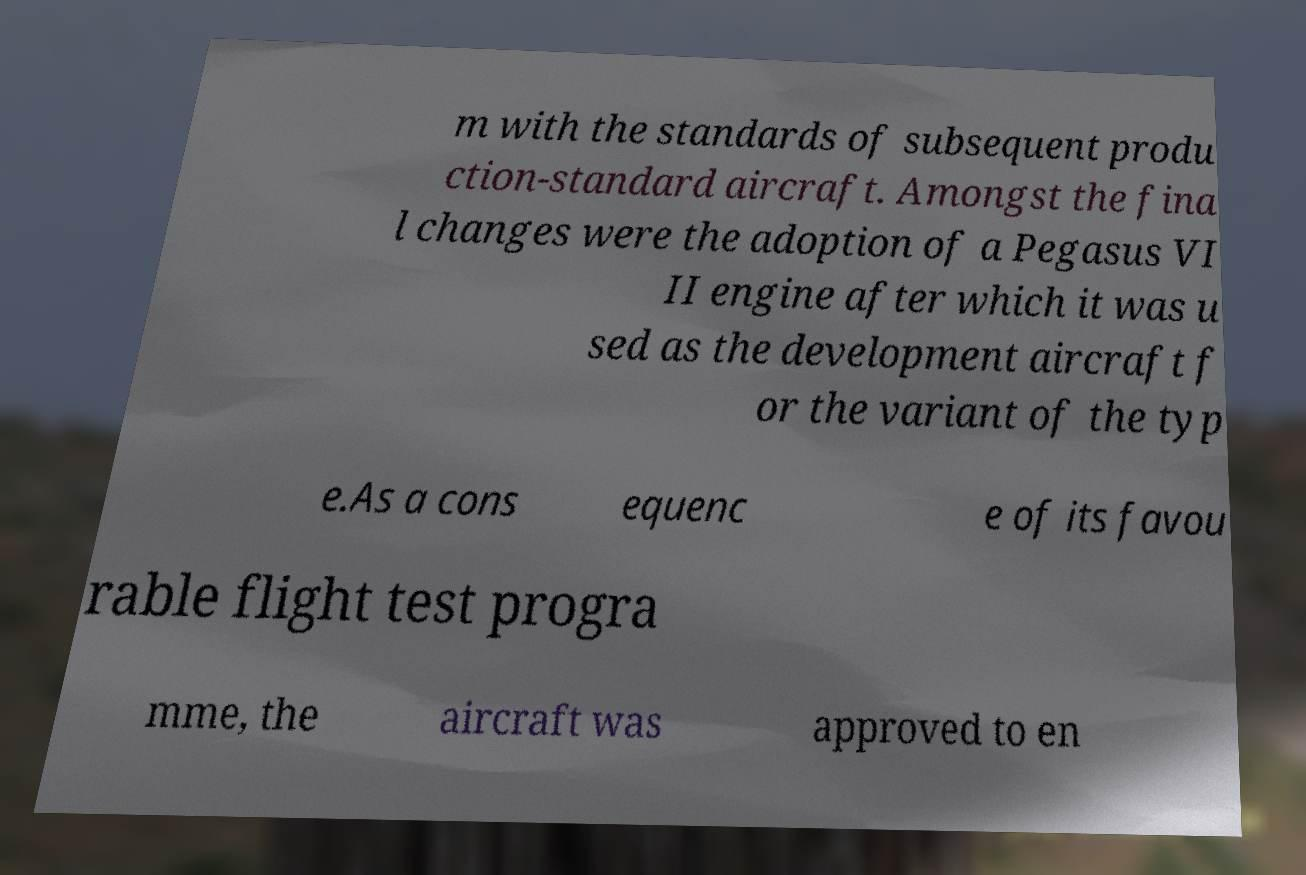Could you extract and type out the text from this image? m with the standards of subsequent produ ction-standard aircraft. Amongst the fina l changes were the adoption of a Pegasus VI II engine after which it was u sed as the development aircraft f or the variant of the typ e.As a cons equenc e of its favou rable flight test progra mme, the aircraft was approved to en 